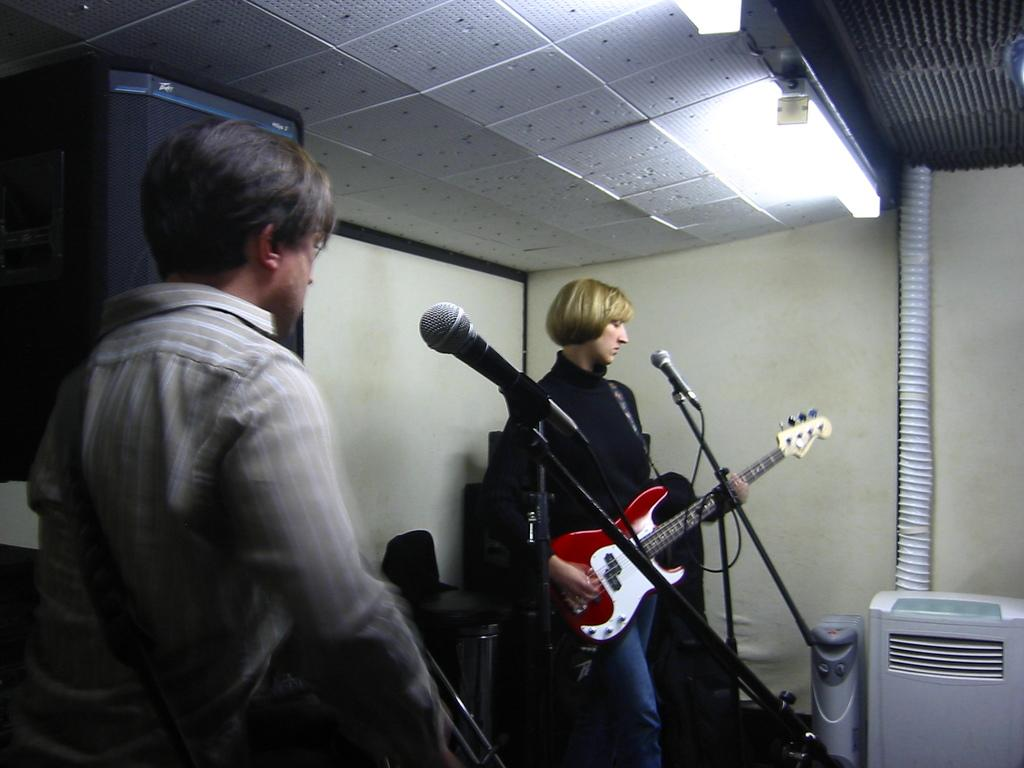How many people are in the image? There are two persons in the image. What are the persons holding in the image? The persons are holding guitars. What object is in front of the persons? There is a microphone in front of the persons. What can be seen in the background of the image? There is a wall and a screen in the background of the image. What type of coil is wrapped around the guitar in the image? There is no coil visible around the guitar in the image. Is there a jail in the background of the image? There is no jail present in the image; only a wall and a screen are visible in the background. 